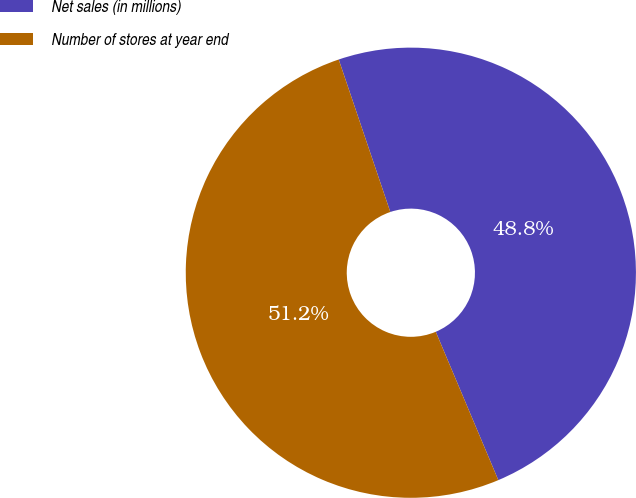Convert chart to OTSL. <chart><loc_0><loc_0><loc_500><loc_500><pie_chart><fcel>Net sales (in millions)<fcel>Number of stores at year end<nl><fcel>48.84%<fcel>51.16%<nl></chart> 